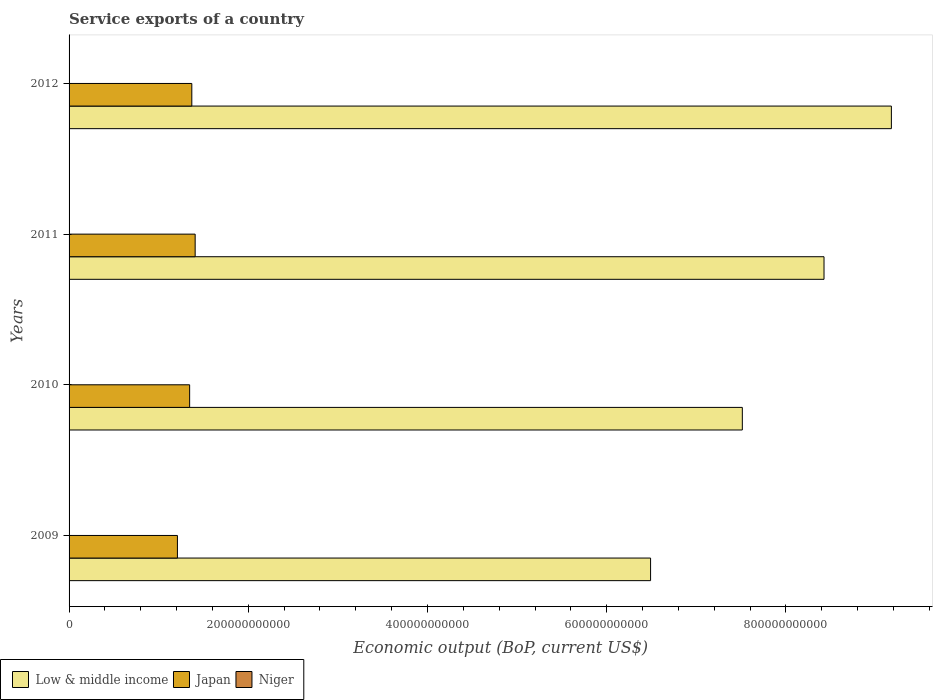How many groups of bars are there?
Your response must be concise. 4. Are the number of bars per tick equal to the number of legend labels?
Ensure brevity in your answer.  Yes. Are the number of bars on each tick of the Y-axis equal?
Give a very brief answer. Yes. How many bars are there on the 4th tick from the bottom?
Your answer should be very brief. 3. What is the label of the 4th group of bars from the top?
Offer a terse response. 2009. What is the service exports in Japan in 2010?
Give a very brief answer. 1.35e+11. Across all years, what is the maximum service exports in Japan?
Give a very brief answer. 1.41e+11. Across all years, what is the minimum service exports in Japan?
Offer a very short reply. 1.21e+11. In which year was the service exports in Niger maximum?
Provide a short and direct response. 2010. In which year was the service exports in Japan minimum?
Provide a short and direct response. 2009. What is the total service exports in Japan in the graph?
Provide a short and direct response. 5.33e+11. What is the difference between the service exports in Niger in 2009 and that in 2011?
Provide a short and direct response. 2.70e+07. What is the difference between the service exports in Low & middle income in 2009 and the service exports in Niger in 2011?
Give a very brief answer. 6.49e+11. What is the average service exports in Niger per year?
Make the answer very short. 9.31e+07. In the year 2012, what is the difference between the service exports in Low & middle income and service exports in Niger?
Keep it short and to the point. 9.18e+11. What is the ratio of the service exports in Low & middle income in 2010 to that in 2011?
Provide a short and direct response. 0.89. Is the difference between the service exports in Low & middle income in 2009 and 2010 greater than the difference between the service exports in Niger in 2009 and 2010?
Your response must be concise. No. What is the difference between the highest and the second highest service exports in Niger?
Make the answer very short. 1.91e+07. What is the difference between the highest and the lowest service exports in Niger?
Your answer should be very brief. 4.62e+07. Is the sum of the service exports in Japan in 2010 and 2011 greater than the maximum service exports in Low & middle income across all years?
Your response must be concise. No. How many bars are there?
Offer a very short reply. 12. Are all the bars in the graph horizontal?
Your answer should be very brief. Yes. How many years are there in the graph?
Your response must be concise. 4. What is the difference between two consecutive major ticks on the X-axis?
Your response must be concise. 2.00e+11. Are the values on the major ticks of X-axis written in scientific E-notation?
Offer a terse response. No. What is the title of the graph?
Ensure brevity in your answer.  Service exports of a country. What is the label or title of the X-axis?
Provide a short and direct response. Economic output (BoP, current US$). What is the Economic output (BoP, current US$) of Low & middle income in 2009?
Keep it short and to the point. 6.49e+11. What is the Economic output (BoP, current US$) of Japan in 2009?
Provide a succinct answer. 1.21e+11. What is the Economic output (BoP, current US$) of Niger in 2009?
Offer a very short reply. 9.99e+07. What is the Economic output (BoP, current US$) in Low & middle income in 2010?
Keep it short and to the point. 7.51e+11. What is the Economic output (BoP, current US$) of Japan in 2010?
Ensure brevity in your answer.  1.35e+11. What is the Economic output (BoP, current US$) in Niger in 2010?
Your answer should be compact. 1.19e+08. What is the Economic output (BoP, current US$) in Low & middle income in 2011?
Provide a succinct answer. 8.42e+11. What is the Economic output (BoP, current US$) in Japan in 2011?
Keep it short and to the point. 1.41e+11. What is the Economic output (BoP, current US$) in Niger in 2011?
Offer a very short reply. 7.29e+07. What is the Economic output (BoP, current US$) in Low & middle income in 2012?
Ensure brevity in your answer.  9.18e+11. What is the Economic output (BoP, current US$) in Japan in 2012?
Provide a succinct answer. 1.37e+11. What is the Economic output (BoP, current US$) of Niger in 2012?
Ensure brevity in your answer.  8.07e+07. Across all years, what is the maximum Economic output (BoP, current US$) in Low & middle income?
Your answer should be compact. 9.18e+11. Across all years, what is the maximum Economic output (BoP, current US$) in Japan?
Ensure brevity in your answer.  1.41e+11. Across all years, what is the maximum Economic output (BoP, current US$) in Niger?
Offer a terse response. 1.19e+08. Across all years, what is the minimum Economic output (BoP, current US$) of Low & middle income?
Make the answer very short. 6.49e+11. Across all years, what is the minimum Economic output (BoP, current US$) in Japan?
Give a very brief answer. 1.21e+11. Across all years, what is the minimum Economic output (BoP, current US$) in Niger?
Your answer should be very brief. 7.29e+07. What is the total Economic output (BoP, current US$) of Low & middle income in the graph?
Your answer should be compact. 3.16e+12. What is the total Economic output (BoP, current US$) in Japan in the graph?
Provide a succinct answer. 5.33e+11. What is the total Economic output (BoP, current US$) in Niger in the graph?
Your answer should be very brief. 3.72e+08. What is the difference between the Economic output (BoP, current US$) of Low & middle income in 2009 and that in 2010?
Your answer should be very brief. -1.02e+11. What is the difference between the Economic output (BoP, current US$) of Japan in 2009 and that in 2010?
Make the answer very short. -1.36e+1. What is the difference between the Economic output (BoP, current US$) of Niger in 2009 and that in 2010?
Your answer should be compact. -1.91e+07. What is the difference between the Economic output (BoP, current US$) of Low & middle income in 2009 and that in 2011?
Give a very brief answer. -1.94e+11. What is the difference between the Economic output (BoP, current US$) in Japan in 2009 and that in 2011?
Offer a very short reply. -1.98e+1. What is the difference between the Economic output (BoP, current US$) of Niger in 2009 and that in 2011?
Keep it short and to the point. 2.70e+07. What is the difference between the Economic output (BoP, current US$) in Low & middle income in 2009 and that in 2012?
Ensure brevity in your answer.  -2.69e+11. What is the difference between the Economic output (BoP, current US$) in Japan in 2009 and that in 2012?
Your answer should be very brief. -1.61e+1. What is the difference between the Economic output (BoP, current US$) in Niger in 2009 and that in 2012?
Make the answer very short. 1.93e+07. What is the difference between the Economic output (BoP, current US$) in Low & middle income in 2010 and that in 2011?
Provide a short and direct response. -9.12e+1. What is the difference between the Economic output (BoP, current US$) in Japan in 2010 and that in 2011?
Offer a very short reply. -6.16e+09. What is the difference between the Economic output (BoP, current US$) of Niger in 2010 and that in 2011?
Make the answer very short. 4.62e+07. What is the difference between the Economic output (BoP, current US$) of Low & middle income in 2010 and that in 2012?
Give a very brief answer. -1.66e+11. What is the difference between the Economic output (BoP, current US$) of Japan in 2010 and that in 2012?
Your response must be concise. -2.42e+09. What is the difference between the Economic output (BoP, current US$) in Niger in 2010 and that in 2012?
Your answer should be compact. 3.84e+07. What is the difference between the Economic output (BoP, current US$) of Low & middle income in 2011 and that in 2012?
Provide a short and direct response. -7.52e+1. What is the difference between the Economic output (BoP, current US$) in Japan in 2011 and that in 2012?
Your response must be concise. 3.74e+09. What is the difference between the Economic output (BoP, current US$) in Niger in 2011 and that in 2012?
Make the answer very short. -7.79e+06. What is the difference between the Economic output (BoP, current US$) in Low & middle income in 2009 and the Economic output (BoP, current US$) in Japan in 2010?
Your answer should be compact. 5.14e+11. What is the difference between the Economic output (BoP, current US$) in Low & middle income in 2009 and the Economic output (BoP, current US$) in Niger in 2010?
Offer a terse response. 6.49e+11. What is the difference between the Economic output (BoP, current US$) in Japan in 2009 and the Economic output (BoP, current US$) in Niger in 2010?
Give a very brief answer. 1.21e+11. What is the difference between the Economic output (BoP, current US$) of Low & middle income in 2009 and the Economic output (BoP, current US$) of Japan in 2011?
Your answer should be compact. 5.08e+11. What is the difference between the Economic output (BoP, current US$) of Low & middle income in 2009 and the Economic output (BoP, current US$) of Niger in 2011?
Offer a terse response. 6.49e+11. What is the difference between the Economic output (BoP, current US$) in Japan in 2009 and the Economic output (BoP, current US$) in Niger in 2011?
Offer a terse response. 1.21e+11. What is the difference between the Economic output (BoP, current US$) in Low & middle income in 2009 and the Economic output (BoP, current US$) in Japan in 2012?
Provide a short and direct response. 5.12e+11. What is the difference between the Economic output (BoP, current US$) in Low & middle income in 2009 and the Economic output (BoP, current US$) in Niger in 2012?
Your response must be concise. 6.49e+11. What is the difference between the Economic output (BoP, current US$) of Japan in 2009 and the Economic output (BoP, current US$) of Niger in 2012?
Make the answer very short. 1.21e+11. What is the difference between the Economic output (BoP, current US$) in Low & middle income in 2010 and the Economic output (BoP, current US$) in Japan in 2011?
Ensure brevity in your answer.  6.11e+11. What is the difference between the Economic output (BoP, current US$) in Low & middle income in 2010 and the Economic output (BoP, current US$) in Niger in 2011?
Give a very brief answer. 7.51e+11. What is the difference between the Economic output (BoP, current US$) in Japan in 2010 and the Economic output (BoP, current US$) in Niger in 2011?
Offer a very short reply. 1.34e+11. What is the difference between the Economic output (BoP, current US$) of Low & middle income in 2010 and the Economic output (BoP, current US$) of Japan in 2012?
Provide a succinct answer. 6.14e+11. What is the difference between the Economic output (BoP, current US$) of Low & middle income in 2010 and the Economic output (BoP, current US$) of Niger in 2012?
Ensure brevity in your answer.  7.51e+11. What is the difference between the Economic output (BoP, current US$) of Japan in 2010 and the Economic output (BoP, current US$) of Niger in 2012?
Offer a very short reply. 1.34e+11. What is the difference between the Economic output (BoP, current US$) of Low & middle income in 2011 and the Economic output (BoP, current US$) of Japan in 2012?
Your response must be concise. 7.05e+11. What is the difference between the Economic output (BoP, current US$) of Low & middle income in 2011 and the Economic output (BoP, current US$) of Niger in 2012?
Keep it short and to the point. 8.42e+11. What is the difference between the Economic output (BoP, current US$) in Japan in 2011 and the Economic output (BoP, current US$) in Niger in 2012?
Your response must be concise. 1.41e+11. What is the average Economic output (BoP, current US$) in Low & middle income per year?
Offer a terse response. 7.90e+11. What is the average Economic output (BoP, current US$) in Japan per year?
Give a very brief answer. 1.33e+11. What is the average Economic output (BoP, current US$) of Niger per year?
Make the answer very short. 9.31e+07. In the year 2009, what is the difference between the Economic output (BoP, current US$) of Low & middle income and Economic output (BoP, current US$) of Japan?
Make the answer very short. 5.28e+11. In the year 2009, what is the difference between the Economic output (BoP, current US$) of Low & middle income and Economic output (BoP, current US$) of Niger?
Make the answer very short. 6.49e+11. In the year 2009, what is the difference between the Economic output (BoP, current US$) in Japan and Economic output (BoP, current US$) in Niger?
Provide a short and direct response. 1.21e+11. In the year 2010, what is the difference between the Economic output (BoP, current US$) of Low & middle income and Economic output (BoP, current US$) of Japan?
Offer a very short reply. 6.17e+11. In the year 2010, what is the difference between the Economic output (BoP, current US$) in Low & middle income and Economic output (BoP, current US$) in Niger?
Your answer should be very brief. 7.51e+11. In the year 2010, what is the difference between the Economic output (BoP, current US$) in Japan and Economic output (BoP, current US$) in Niger?
Keep it short and to the point. 1.34e+11. In the year 2011, what is the difference between the Economic output (BoP, current US$) of Low & middle income and Economic output (BoP, current US$) of Japan?
Your answer should be very brief. 7.02e+11. In the year 2011, what is the difference between the Economic output (BoP, current US$) of Low & middle income and Economic output (BoP, current US$) of Niger?
Provide a succinct answer. 8.42e+11. In the year 2011, what is the difference between the Economic output (BoP, current US$) in Japan and Economic output (BoP, current US$) in Niger?
Your response must be concise. 1.41e+11. In the year 2012, what is the difference between the Economic output (BoP, current US$) of Low & middle income and Economic output (BoP, current US$) of Japan?
Give a very brief answer. 7.81e+11. In the year 2012, what is the difference between the Economic output (BoP, current US$) in Low & middle income and Economic output (BoP, current US$) in Niger?
Make the answer very short. 9.18e+11. In the year 2012, what is the difference between the Economic output (BoP, current US$) in Japan and Economic output (BoP, current US$) in Niger?
Provide a short and direct response. 1.37e+11. What is the ratio of the Economic output (BoP, current US$) in Low & middle income in 2009 to that in 2010?
Offer a terse response. 0.86. What is the ratio of the Economic output (BoP, current US$) of Japan in 2009 to that in 2010?
Offer a very short reply. 0.9. What is the ratio of the Economic output (BoP, current US$) in Niger in 2009 to that in 2010?
Your answer should be very brief. 0.84. What is the ratio of the Economic output (BoP, current US$) of Low & middle income in 2009 to that in 2011?
Offer a very short reply. 0.77. What is the ratio of the Economic output (BoP, current US$) of Japan in 2009 to that in 2011?
Provide a succinct answer. 0.86. What is the ratio of the Economic output (BoP, current US$) in Niger in 2009 to that in 2011?
Your answer should be compact. 1.37. What is the ratio of the Economic output (BoP, current US$) of Low & middle income in 2009 to that in 2012?
Your response must be concise. 0.71. What is the ratio of the Economic output (BoP, current US$) in Japan in 2009 to that in 2012?
Ensure brevity in your answer.  0.88. What is the ratio of the Economic output (BoP, current US$) of Niger in 2009 to that in 2012?
Keep it short and to the point. 1.24. What is the ratio of the Economic output (BoP, current US$) in Low & middle income in 2010 to that in 2011?
Offer a terse response. 0.89. What is the ratio of the Economic output (BoP, current US$) of Japan in 2010 to that in 2011?
Your response must be concise. 0.96. What is the ratio of the Economic output (BoP, current US$) of Niger in 2010 to that in 2011?
Keep it short and to the point. 1.63. What is the ratio of the Economic output (BoP, current US$) of Low & middle income in 2010 to that in 2012?
Give a very brief answer. 0.82. What is the ratio of the Economic output (BoP, current US$) in Japan in 2010 to that in 2012?
Your answer should be very brief. 0.98. What is the ratio of the Economic output (BoP, current US$) of Niger in 2010 to that in 2012?
Your answer should be compact. 1.48. What is the ratio of the Economic output (BoP, current US$) in Low & middle income in 2011 to that in 2012?
Give a very brief answer. 0.92. What is the ratio of the Economic output (BoP, current US$) in Japan in 2011 to that in 2012?
Offer a terse response. 1.03. What is the ratio of the Economic output (BoP, current US$) in Niger in 2011 to that in 2012?
Provide a succinct answer. 0.9. What is the difference between the highest and the second highest Economic output (BoP, current US$) in Low & middle income?
Your answer should be very brief. 7.52e+1. What is the difference between the highest and the second highest Economic output (BoP, current US$) of Japan?
Your answer should be very brief. 3.74e+09. What is the difference between the highest and the second highest Economic output (BoP, current US$) in Niger?
Make the answer very short. 1.91e+07. What is the difference between the highest and the lowest Economic output (BoP, current US$) in Low & middle income?
Ensure brevity in your answer.  2.69e+11. What is the difference between the highest and the lowest Economic output (BoP, current US$) of Japan?
Offer a terse response. 1.98e+1. What is the difference between the highest and the lowest Economic output (BoP, current US$) of Niger?
Give a very brief answer. 4.62e+07. 